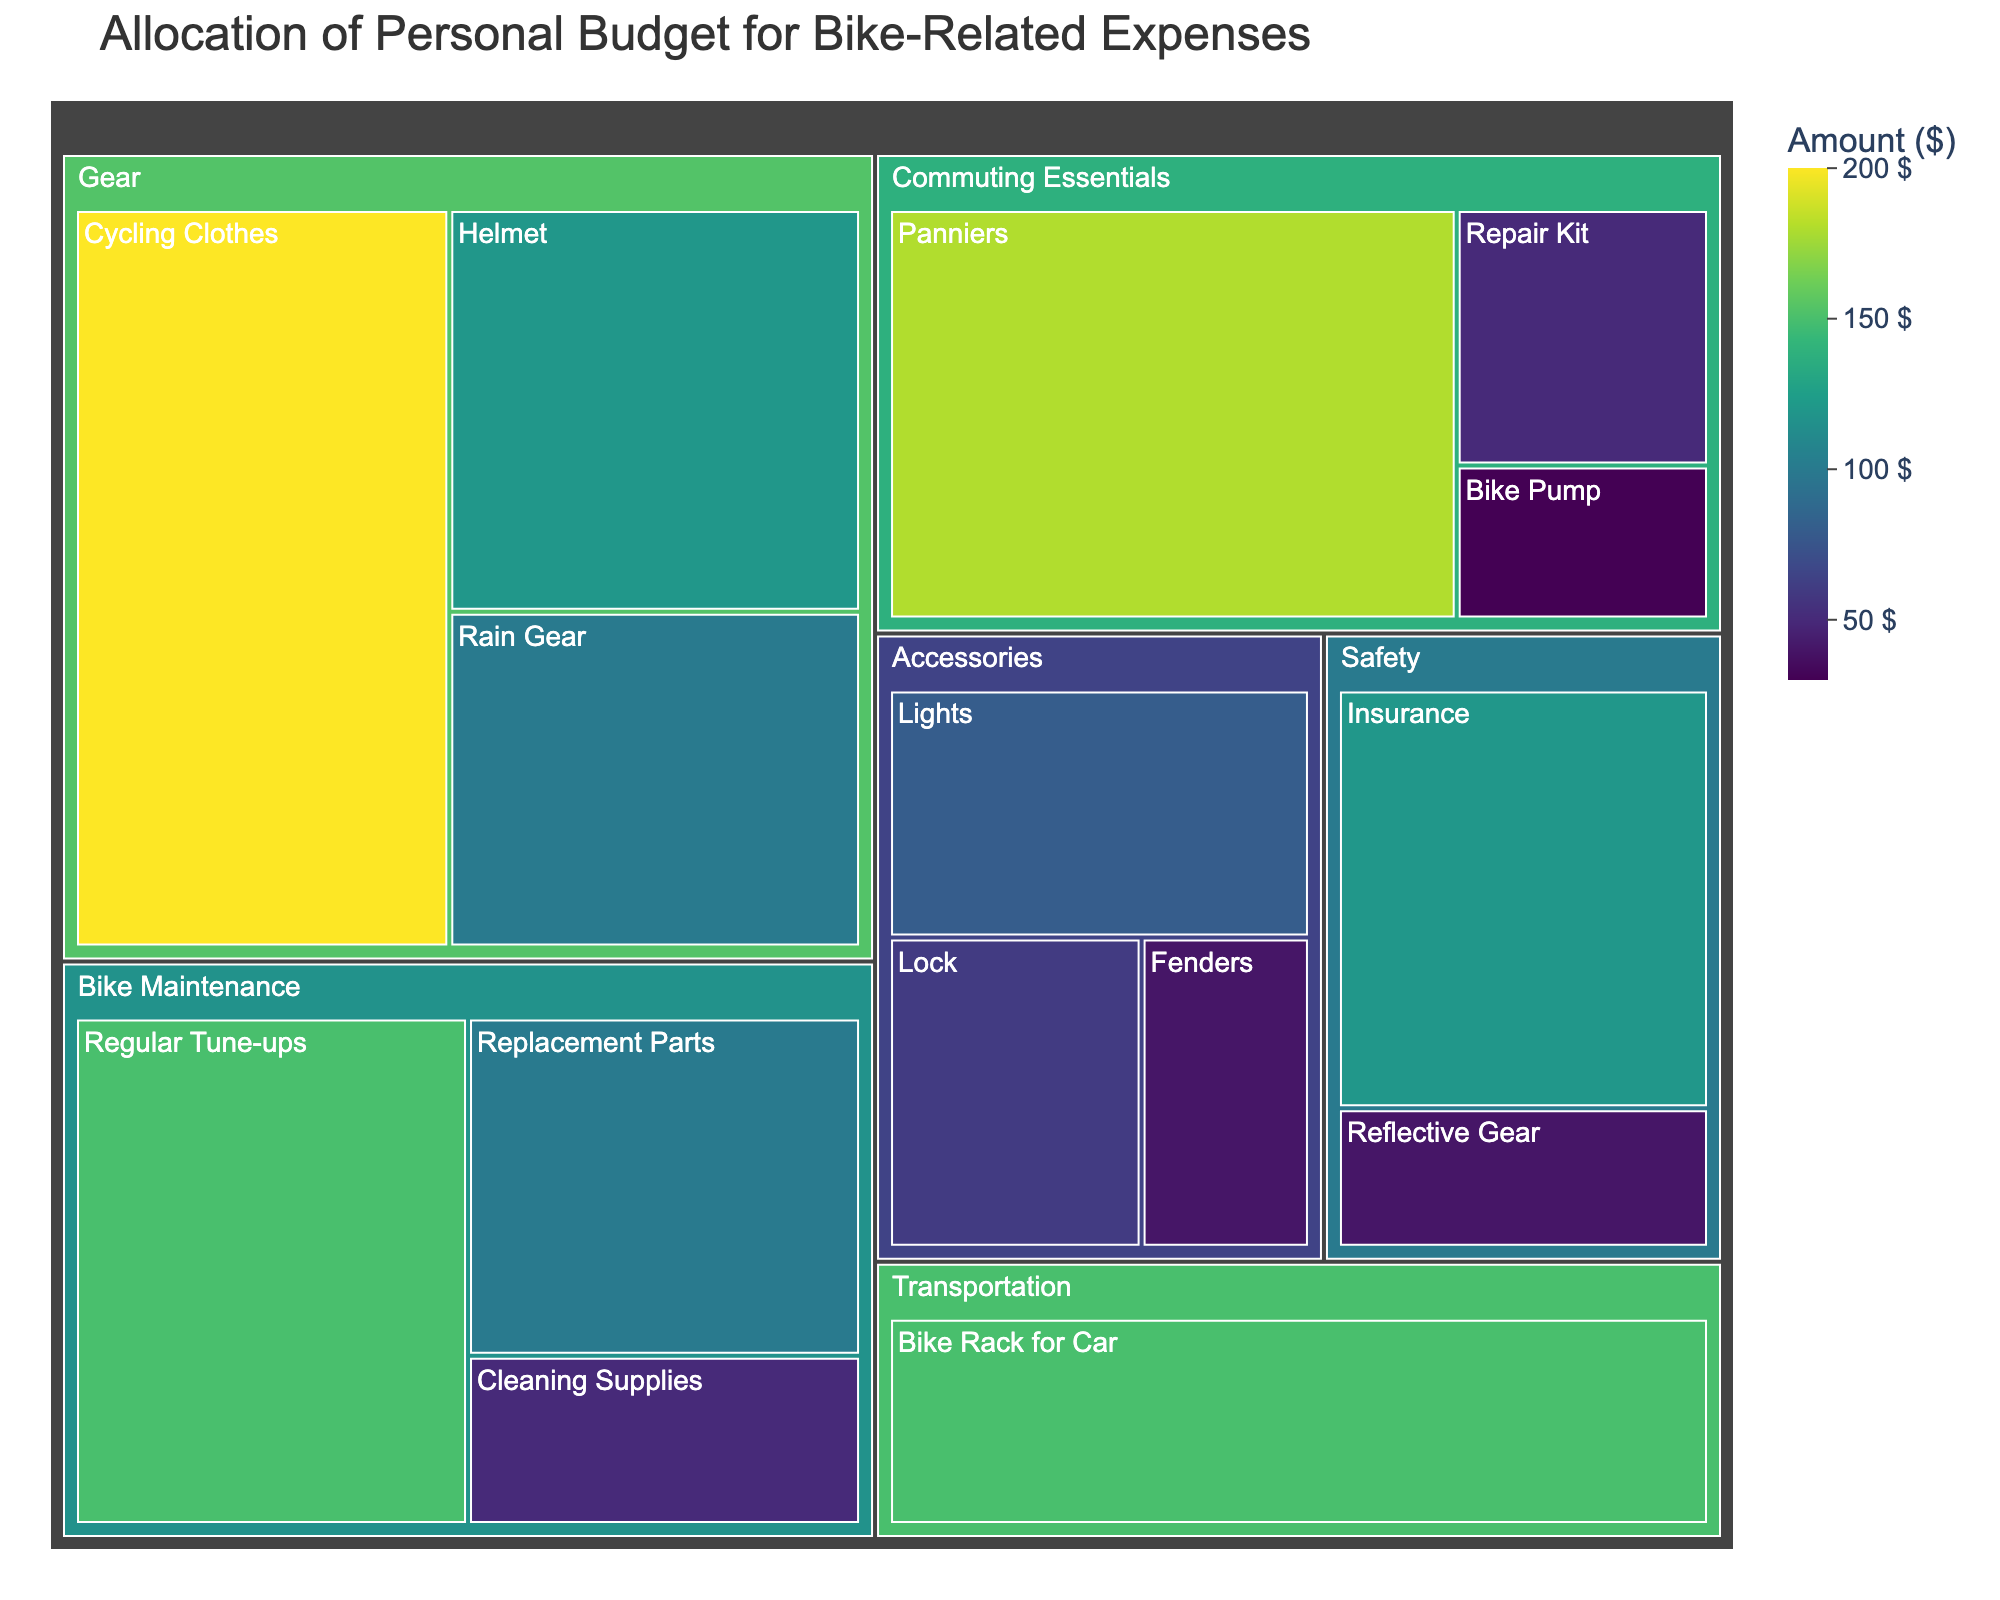Which category has the highest allocation in the budget? By observing the Treemap, the category with the largest area represents the highest allocation.
Answer: Gear What is the total amount allocated to Accessories? The total amount for Accessories is the sum of Lights ($80), Lock ($60), and Fenders ($40). So, 80 + 60 + 40 = 180.
Answer: 180 Which subcategory within the category "Commuting Essentials" has the least allocation? By comparing the areas of subcategories within "Commuting Essentials," the smallest area represents the least allocation.
Answer: Bike Pump How does the amount allocated to Helmet compare to Insurance? First, check the allocation for both subcategories. Helmet has $120, and Insurance also has $120, so they are equal.
Answer: Equal What is the average value allocated to Safety subcategories? Sum the values of Reflective Gear ($40) and Insurance ($120), then divide by the number of subcategories. (40 + 120) / 2 = 80.
Answer: 80 What is the total amount allocated to Bike Maintenance? Add the values of Regular Tune-ups ($150), Replacement Parts ($100), and Cleaning Supplies ($50). 150 + 100 + 50 = 300.
Answer: 300 Which subcategory under Gear has the highest allocation? By observing the areas of subcategories under Gear, the largest area represents the highest allocation.
Answer: Cycling Clothes How much more is allocated to Panniers compared to the Bike Rack for Car? Panniers have $180 allocated, and Bike Rack for Car has $150 allocated. The difference is 180 - 150 = 30.
Answer: 30 Is the allocation for Regular Tune-ups greater than the combined allocation for Fenders and Rain Gear? Regular Tune-ups are $150. Fenders and Rain Gear together are $40 + $100 = $140. Since $150 is greater than $140, the answer is yes.
Answer: Yes 